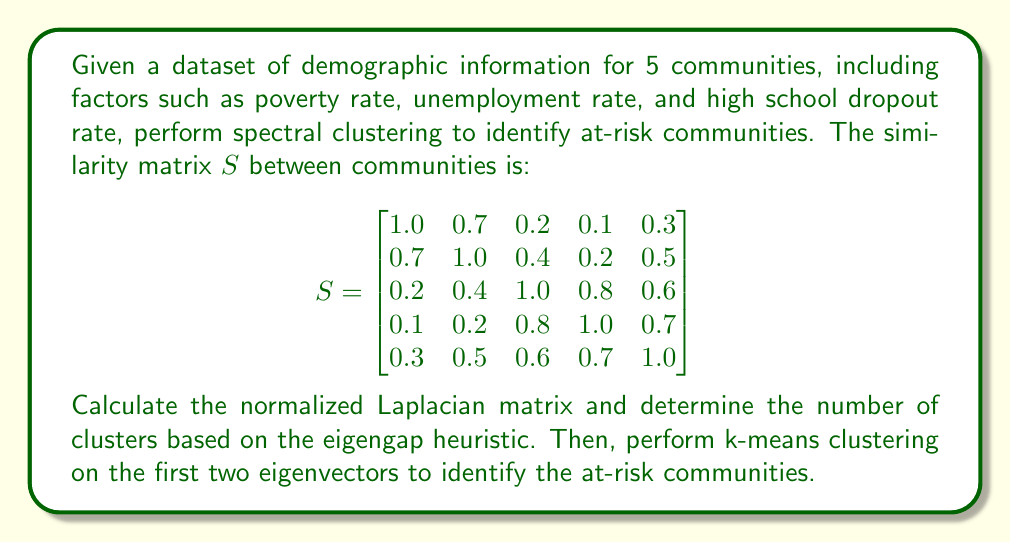Solve this math problem. 1. Calculate the degree matrix $D$:
   $$D = \text{diag}(2.3, 2.8, 3.0, 2.8, 3.1)$$

2. Compute the normalized Laplacian matrix $L_{\text{sym}}$:
   $$L_{\text{sym}} = I - D^{-1/2}SD^{-1/2}$$

3. Calculate eigenvalues of $L_{\text{sym}}$:
   $$\lambda_1 \approx 0, \lambda_2 \approx 0.2198, \lambda_3 \approx 0.4126, \lambda_4 \approx 0.6842, \lambda_5 \approx 1.6834$$

4. Apply eigengap heuristic:
   The largest gap is between $\lambda_2$ and $\lambda_3$, suggesting 2 clusters.

5. Compute the first two eigenvectors $u_1$ and $u_2$ of $L_{\text{sym}}$:
   $$u_1 \approx [-0.4472, -0.5345, -0.4472, -0.3873, -0.4026]^T$$
   $$u_2 \approx [-0.6708, -0.3354, 0.4472, 0.4472, 0.1118]^T$$

6. Form matrix $U \in \mathbb{R}^{5 \times 2}$ with $u_1$ and $u_2$ as columns.

7. Normalize rows of $U$ to have unit length:
   $$T_{ij} = \frac{U_{ij}}{(\sum_k U_{ik}^2)^{1/2}}$$

8. Perform k-means clustering on rows of $T$ with $k=2$.

9. Assign original points to clusters based on k-means results.

The communities are clustered into two groups: {1, 2} and {3, 4, 5}. The first group (communities 1 and 2) is identified as the at-risk cluster due to their higher similarity in demographic factors associated with social issues.
Answer: Communities 1 and 2 are identified as at-risk. 